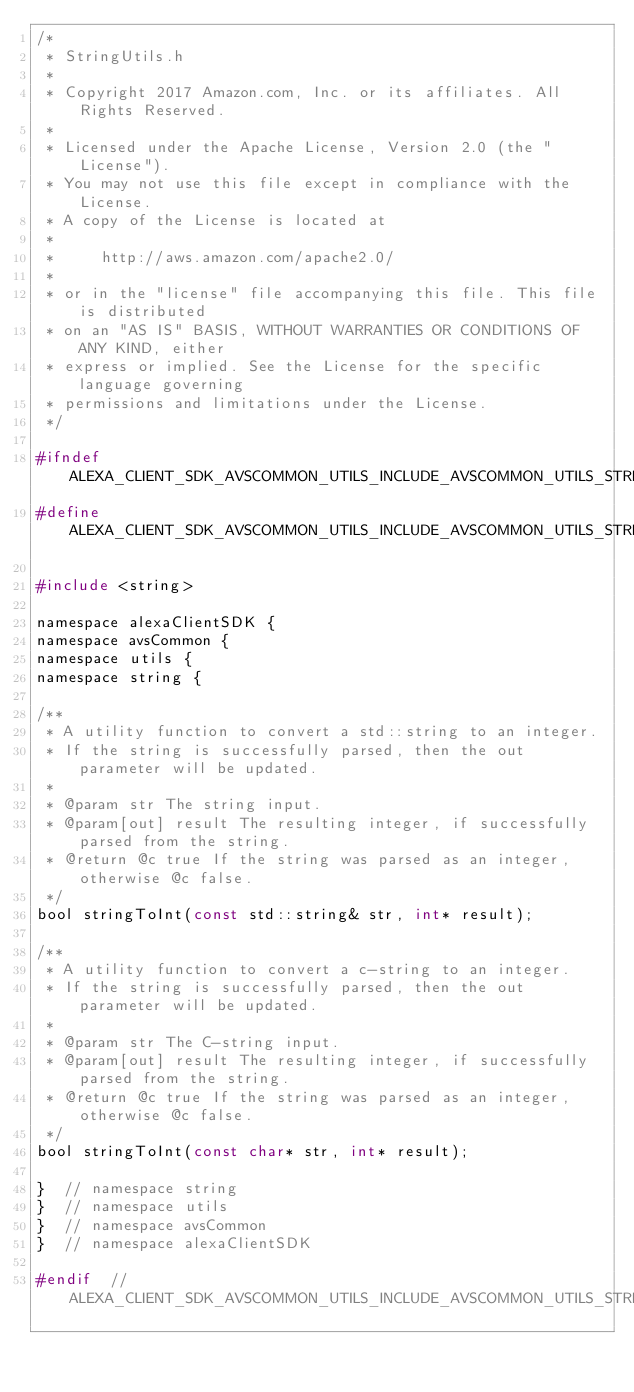<code> <loc_0><loc_0><loc_500><loc_500><_C_>/*
 * StringUtils.h
 *
 * Copyright 2017 Amazon.com, Inc. or its affiliates. All Rights Reserved.
 *
 * Licensed under the Apache License, Version 2.0 (the "License").
 * You may not use this file except in compliance with the License.
 * A copy of the License is located at
 *
 *     http://aws.amazon.com/apache2.0/
 *
 * or in the "license" file accompanying this file. This file is distributed
 * on an "AS IS" BASIS, WITHOUT WARRANTIES OR CONDITIONS OF ANY KIND, either
 * express or implied. See the License for the specific language governing
 * permissions and limitations under the License.
 */

#ifndef ALEXA_CLIENT_SDK_AVSCOMMON_UTILS_INCLUDE_AVSCOMMON_UTILS_STRING_STRINGUTILS_H_
#define ALEXA_CLIENT_SDK_AVSCOMMON_UTILS_INCLUDE_AVSCOMMON_UTILS_STRING_STRINGUTILS_H_

#include <string>

namespace alexaClientSDK {
namespace avsCommon {
namespace utils {
namespace string {

/**
 * A utility function to convert a std::string to an integer.
 * If the string is successfully parsed, then the out parameter will be updated.
 *
 * @param str The string input.
 * @param[out] result The resulting integer, if successfully parsed from the string.
 * @return @c true If the string was parsed as an integer, otherwise @c false.
 */
bool stringToInt(const std::string& str, int* result);

/**
 * A utility function to convert a c-string to an integer.
 * If the string is successfully parsed, then the out parameter will be updated.
 *
 * @param str The C-string input.
 * @param[out] result The resulting integer, if successfully parsed from the string.
 * @return @c true If the string was parsed as an integer, otherwise @c false.
 */
bool stringToInt(const char* str, int* result);

}  // namespace string
}  // namespace utils
}  // namespace avsCommon
}  // namespace alexaClientSDK

#endif  // ALEXA_CLIENT_SDK_AVSCOMMON_UTILS_INCLUDE_AVSCOMMON_UTILS_STRING_STRINGUTILS_H_
</code> 